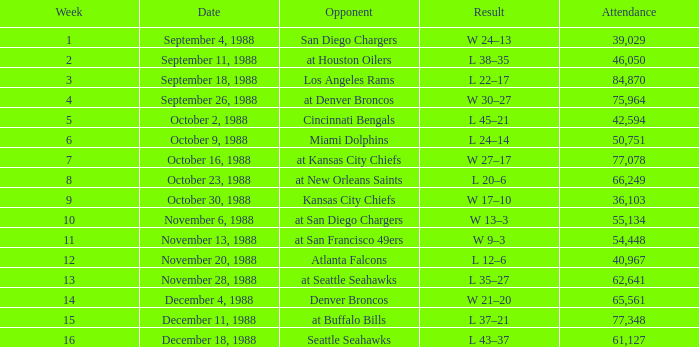Would you be able to parse every entry in this table? {'header': ['Week', 'Date', 'Opponent', 'Result', 'Attendance'], 'rows': [['1', 'September 4, 1988', 'San Diego Chargers', 'W 24–13', '39,029'], ['2', 'September 11, 1988', 'at Houston Oilers', 'L 38–35', '46,050'], ['3', 'September 18, 1988', 'Los Angeles Rams', 'L 22–17', '84,870'], ['4', 'September 26, 1988', 'at Denver Broncos', 'W 30–27', '75,964'], ['5', 'October 2, 1988', 'Cincinnati Bengals', 'L 45–21', '42,594'], ['6', 'October 9, 1988', 'Miami Dolphins', 'L 24–14', '50,751'], ['7', 'October 16, 1988', 'at Kansas City Chiefs', 'W 27–17', '77,078'], ['8', 'October 23, 1988', 'at New Orleans Saints', 'L 20–6', '66,249'], ['9', 'October 30, 1988', 'Kansas City Chiefs', 'W 17–10', '36,103'], ['10', 'November 6, 1988', 'at San Diego Chargers', 'W 13–3', '55,134'], ['11', 'November 13, 1988', 'at San Francisco 49ers', 'W 9–3', '54,448'], ['12', 'November 20, 1988', 'Atlanta Falcons', 'L 12–6', '40,967'], ['13', 'November 28, 1988', 'at Seattle Seahawks', 'L 35–27', '62,641'], ['14', 'December 4, 1988', 'Denver Broncos', 'W 21–20', '65,561'], ['15', 'December 11, 1988', 'at Buffalo Bills', 'L 37–21', '77,348'], ['16', 'December 18, 1988', 'Seattle Seahawks', 'L 43–37', '61,127']]} What was the date in week 13? November 28, 1988. 